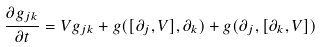<formula> <loc_0><loc_0><loc_500><loc_500>\frac { \partial g _ { j k } } { \partial t } = V g _ { j k } + g ( [ \partial _ { j } , V ] , \partial _ { k } ) + g ( \partial _ { j } , [ \partial _ { k } , V ] )</formula> 